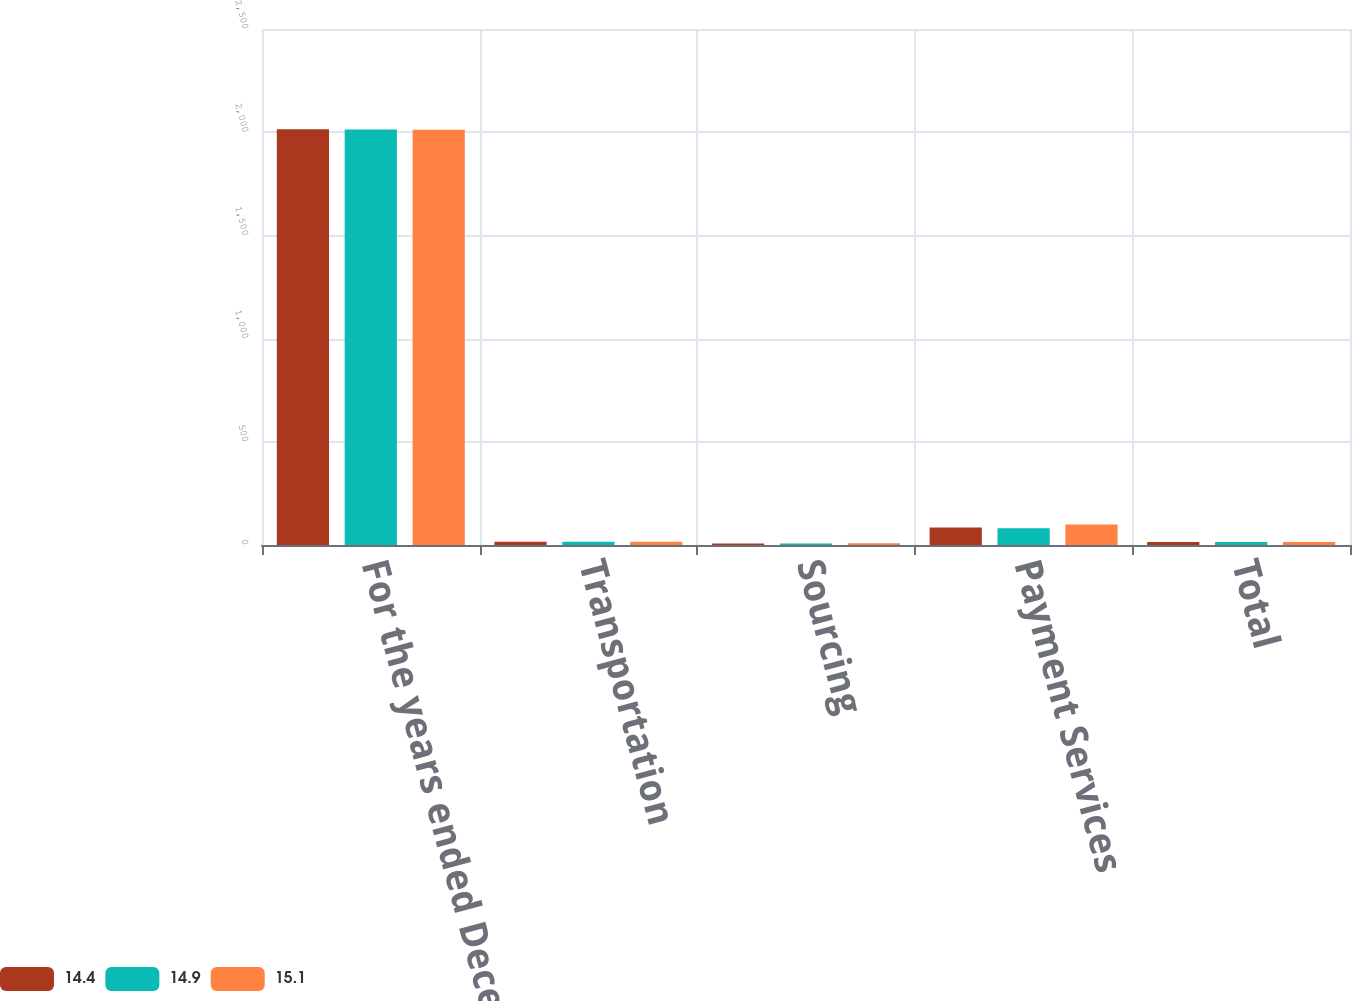Convert chart. <chart><loc_0><loc_0><loc_500><loc_500><stacked_bar_chart><ecel><fcel>For the years ended December<fcel>Transportation<fcel>Sourcing<fcel>Payment Services<fcel>Total<nl><fcel>14.4<fcel>2014<fcel>15.8<fcel>7.5<fcel>85.2<fcel>14.9<nl><fcel>14.9<fcel>2013<fcel>15.3<fcel>7.6<fcel>81.2<fcel>14.4<nl><fcel>15.1<fcel>2012<fcel>15.8<fcel>8.4<fcel>99<fcel>15.1<nl></chart> 